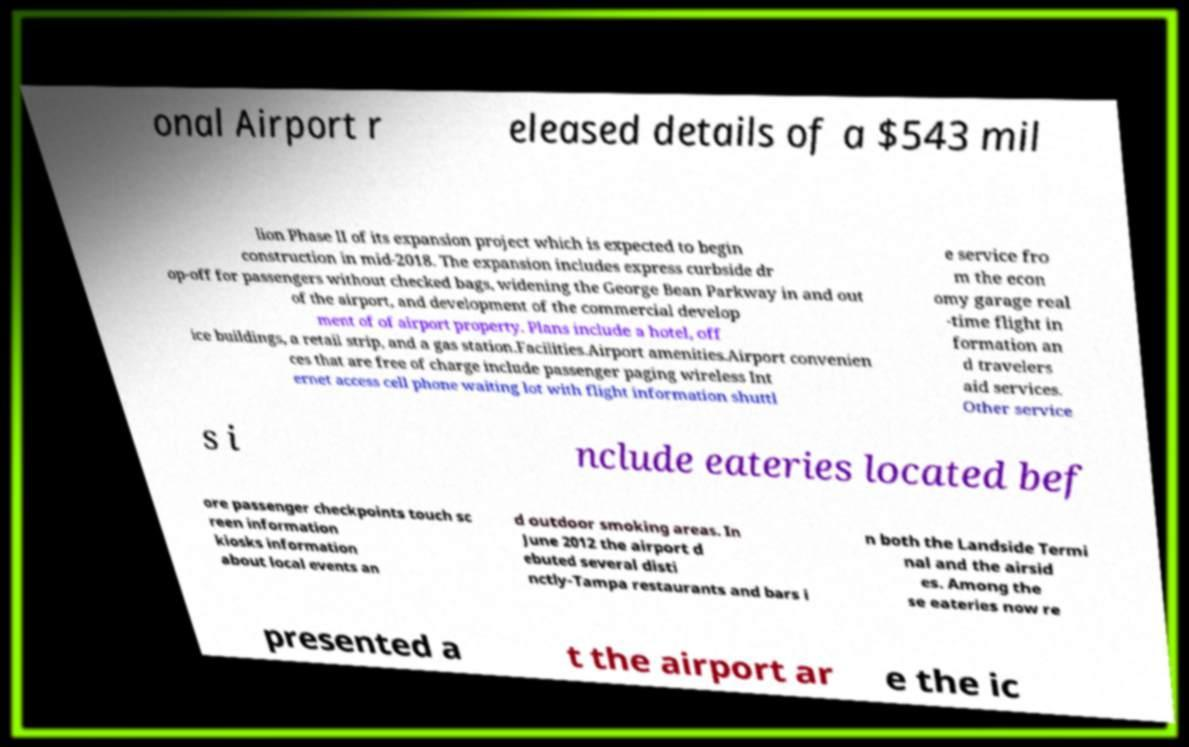Could you extract and type out the text from this image? onal Airport r eleased details of a $543 mil lion Phase II of its expansion project which is expected to begin construction in mid-2018. The expansion includes express curbside dr op-off for passengers without checked bags, widening the George Bean Parkway in and out of the airport, and development of the commercial develop ment of of airport property. Plans include a hotel, off ice buildings, a retail strip, and a gas station.Facilities.Airport amenities.Airport convenien ces that are free of charge include passenger paging wireless Int ernet access cell phone waiting lot with flight information shuttl e service fro m the econ omy garage real -time flight in formation an d travelers aid services. Other service s i nclude eateries located bef ore passenger checkpoints touch sc reen information kiosks information about local events an d outdoor smoking areas. In June 2012 the airport d ebuted several disti nctly-Tampa restaurants and bars i n both the Landside Termi nal and the airsid es. Among the se eateries now re presented a t the airport ar e the ic 